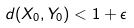<formula> <loc_0><loc_0><loc_500><loc_500>d ( X _ { 0 } , Y _ { 0 } ) < 1 + \epsilon</formula> 